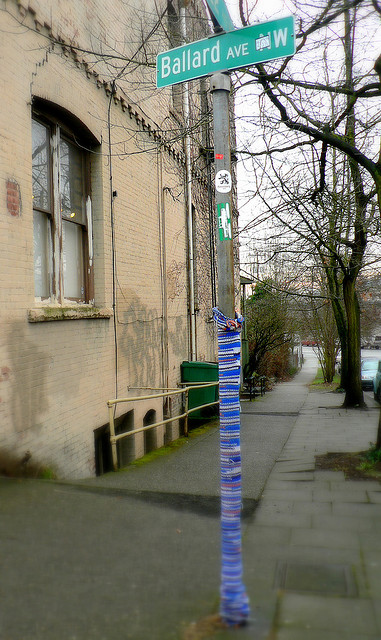Read all the text in this image. Ballard AVE W 